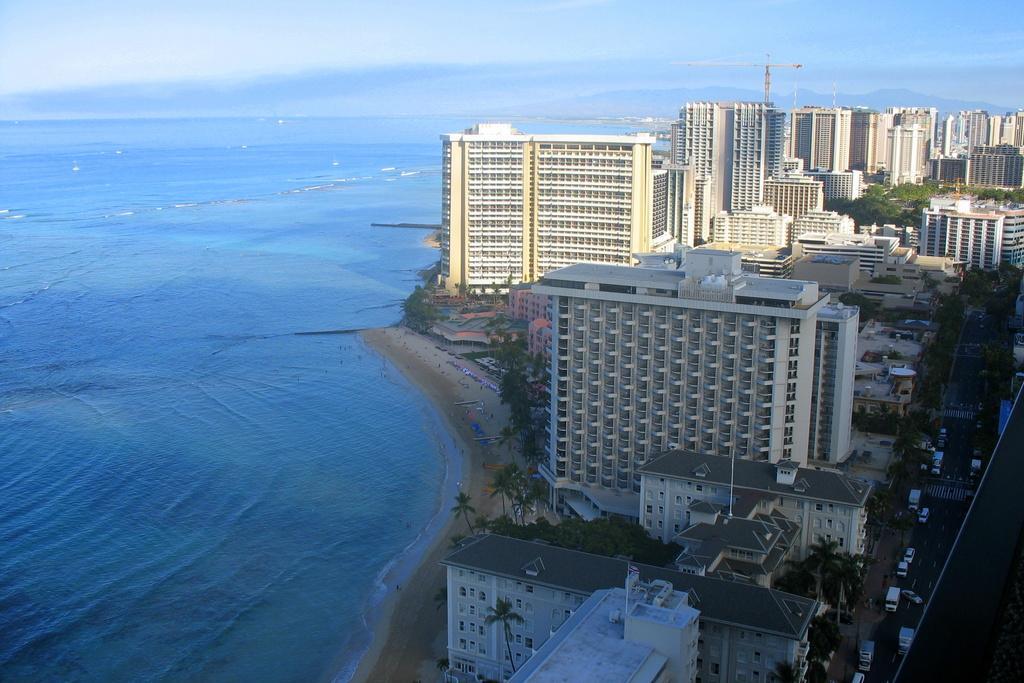Describe this image in one or two sentences. In this image we can see so many buildings, there are some trees, vehicles and water. In the background, we can see the sky with clouds. 